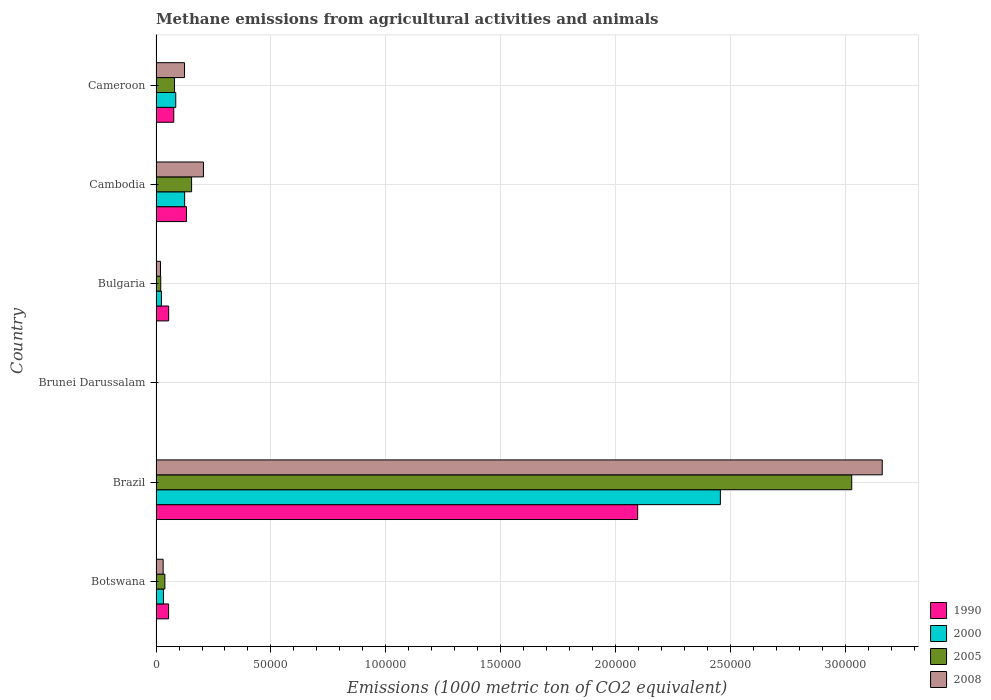How many groups of bars are there?
Offer a very short reply. 6. Are the number of bars on each tick of the Y-axis equal?
Provide a short and direct response. Yes. What is the label of the 2nd group of bars from the top?
Give a very brief answer. Cambodia. What is the amount of methane emitted in 1990 in Cambodia?
Ensure brevity in your answer.  1.32e+04. Across all countries, what is the maximum amount of methane emitted in 2000?
Your response must be concise. 2.45e+05. Across all countries, what is the minimum amount of methane emitted in 1990?
Ensure brevity in your answer.  12.5. In which country was the amount of methane emitted in 2005 minimum?
Provide a succinct answer. Brunei Darussalam. What is the total amount of methane emitted in 2000 in the graph?
Offer a terse response. 2.72e+05. What is the difference between the amount of methane emitted in 2008 in Cambodia and that in Cameroon?
Ensure brevity in your answer.  8220.9. What is the difference between the amount of methane emitted in 2008 in Cambodia and the amount of methane emitted in 2005 in Bulgaria?
Offer a terse response. 1.86e+04. What is the average amount of methane emitted in 2000 per country?
Provide a short and direct response. 4.54e+04. What is the difference between the amount of methane emitted in 2008 and amount of methane emitted in 2000 in Brazil?
Ensure brevity in your answer.  7.04e+04. In how many countries, is the amount of methane emitted in 2008 greater than 250000 1000 metric ton?
Make the answer very short. 1. What is the ratio of the amount of methane emitted in 2005 in Brunei Darussalam to that in Bulgaria?
Offer a very short reply. 0.01. Is the difference between the amount of methane emitted in 2008 in Botswana and Brunei Darussalam greater than the difference between the amount of methane emitted in 2000 in Botswana and Brunei Darussalam?
Keep it short and to the point. No. What is the difference between the highest and the second highest amount of methane emitted in 1990?
Offer a terse response. 1.96e+05. What is the difference between the highest and the lowest amount of methane emitted in 2000?
Offer a terse response. 2.45e+05. In how many countries, is the amount of methane emitted in 2000 greater than the average amount of methane emitted in 2000 taken over all countries?
Offer a very short reply. 1. Is it the case that in every country, the sum of the amount of methane emitted in 2005 and amount of methane emitted in 2008 is greater than the sum of amount of methane emitted in 2000 and amount of methane emitted in 1990?
Your response must be concise. No. What does the 4th bar from the top in Brazil represents?
Ensure brevity in your answer.  1990. What does the 4th bar from the bottom in Brazil represents?
Offer a terse response. 2008. Is it the case that in every country, the sum of the amount of methane emitted in 2008 and amount of methane emitted in 2005 is greater than the amount of methane emitted in 1990?
Your answer should be compact. No. Are all the bars in the graph horizontal?
Offer a terse response. Yes. How many countries are there in the graph?
Offer a terse response. 6. What is the difference between two consecutive major ticks on the X-axis?
Ensure brevity in your answer.  5.00e+04. Where does the legend appear in the graph?
Offer a terse response. Bottom right. How are the legend labels stacked?
Make the answer very short. Vertical. What is the title of the graph?
Provide a succinct answer. Methane emissions from agricultural activities and animals. What is the label or title of the X-axis?
Offer a terse response. Emissions (1000 metric ton of CO2 equivalent). What is the label or title of the Y-axis?
Your answer should be compact. Country. What is the Emissions (1000 metric ton of CO2 equivalent) in 1990 in Botswana?
Your answer should be compact. 5471.2. What is the Emissions (1000 metric ton of CO2 equivalent) in 2000 in Botswana?
Keep it short and to the point. 3234. What is the Emissions (1000 metric ton of CO2 equivalent) of 2005 in Botswana?
Your response must be concise. 3850.6. What is the Emissions (1000 metric ton of CO2 equivalent) in 2008 in Botswana?
Make the answer very short. 3096.4. What is the Emissions (1000 metric ton of CO2 equivalent) in 1990 in Brazil?
Your answer should be very brief. 2.10e+05. What is the Emissions (1000 metric ton of CO2 equivalent) of 2000 in Brazil?
Give a very brief answer. 2.45e+05. What is the Emissions (1000 metric ton of CO2 equivalent) of 2005 in Brazil?
Offer a very short reply. 3.03e+05. What is the Emissions (1000 metric ton of CO2 equivalent) in 2008 in Brazil?
Offer a terse response. 3.16e+05. What is the Emissions (1000 metric ton of CO2 equivalent) in 2008 in Brunei Darussalam?
Provide a short and direct response. 14.3. What is the Emissions (1000 metric ton of CO2 equivalent) in 1990 in Bulgaria?
Offer a very short reply. 5498.3. What is the Emissions (1000 metric ton of CO2 equivalent) of 2000 in Bulgaria?
Provide a succinct answer. 2359.5. What is the Emissions (1000 metric ton of CO2 equivalent) of 2005 in Bulgaria?
Offer a very short reply. 2055.2. What is the Emissions (1000 metric ton of CO2 equivalent) of 2008 in Bulgaria?
Give a very brief answer. 1942.2. What is the Emissions (1000 metric ton of CO2 equivalent) in 1990 in Cambodia?
Your response must be concise. 1.32e+04. What is the Emissions (1000 metric ton of CO2 equivalent) in 2000 in Cambodia?
Your response must be concise. 1.25e+04. What is the Emissions (1000 metric ton of CO2 equivalent) of 2005 in Cambodia?
Your response must be concise. 1.55e+04. What is the Emissions (1000 metric ton of CO2 equivalent) of 2008 in Cambodia?
Ensure brevity in your answer.  2.06e+04. What is the Emissions (1000 metric ton of CO2 equivalent) of 1990 in Cameroon?
Keep it short and to the point. 7719.8. What is the Emissions (1000 metric ton of CO2 equivalent) of 2000 in Cameroon?
Make the answer very short. 8579.6. What is the Emissions (1000 metric ton of CO2 equivalent) of 2005 in Cameroon?
Offer a very short reply. 8047.3. What is the Emissions (1000 metric ton of CO2 equivalent) in 2008 in Cameroon?
Provide a succinct answer. 1.24e+04. Across all countries, what is the maximum Emissions (1000 metric ton of CO2 equivalent) in 1990?
Your response must be concise. 2.10e+05. Across all countries, what is the maximum Emissions (1000 metric ton of CO2 equivalent) of 2000?
Give a very brief answer. 2.45e+05. Across all countries, what is the maximum Emissions (1000 metric ton of CO2 equivalent) of 2005?
Offer a terse response. 3.03e+05. Across all countries, what is the maximum Emissions (1000 metric ton of CO2 equivalent) of 2008?
Provide a succinct answer. 3.16e+05. Across all countries, what is the minimum Emissions (1000 metric ton of CO2 equivalent) in 2005?
Provide a succinct answer. 14.1. What is the total Emissions (1000 metric ton of CO2 equivalent) of 1990 in the graph?
Make the answer very short. 2.41e+05. What is the total Emissions (1000 metric ton of CO2 equivalent) in 2000 in the graph?
Provide a short and direct response. 2.72e+05. What is the total Emissions (1000 metric ton of CO2 equivalent) of 2005 in the graph?
Offer a very short reply. 3.32e+05. What is the total Emissions (1000 metric ton of CO2 equivalent) of 2008 in the graph?
Give a very brief answer. 3.54e+05. What is the difference between the Emissions (1000 metric ton of CO2 equivalent) of 1990 in Botswana and that in Brazil?
Your answer should be very brief. -2.04e+05. What is the difference between the Emissions (1000 metric ton of CO2 equivalent) of 2000 in Botswana and that in Brazil?
Your answer should be compact. -2.42e+05. What is the difference between the Emissions (1000 metric ton of CO2 equivalent) in 2005 in Botswana and that in Brazil?
Keep it short and to the point. -2.99e+05. What is the difference between the Emissions (1000 metric ton of CO2 equivalent) of 2008 in Botswana and that in Brazil?
Keep it short and to the point. -3.13e+05. What is the difference between the Emissions (1000 metric ton of CO2 equivalent) in 1990 in Botswana and that in Brunei Darussalam?
Give a very brief answer. 5458.7. What is the difference between the Emissions (1000 metric ton of CO2 equivalent) of 2000 in Botswana and that in Brunei Darussalam?
Your answer should be very brief. 3218.7. What is the difference between the Emissions (1000 metric ton of CO2 equivalent) of 2005 in Botswana and that in Brunei Darussalam?
Your answer should be very brief. 3836.5. What is the difference between the Emissions (1000 metric ton of CO2 equivalent) of 2008 in Botswana and that in Brunei Darussalam?
Your response must be concise. 3082.1. What is the difference between the Emissions (1000 metric ton of CO2 equivalent) in 1990 in Botswana and that in Bulgaria?
Offer a very short reply. -27.1. What is the difference between the Emissions (1000 metric ton of CO2 equivalent) in 2000 in Botswana and that in Bulgaria?
Give a very brief answer. 874.5. What is the difference between the Emissions (1000 metric ton of CO2 equivalent) of 2005 in Botswana and that in Bulgaria?
Ensure brevity in your answer.  1795.4. What is the difference between the Emissions (1000 metric ton of CO2 equivalent) in 2008 in Botswana and that in Bulgaria?
Your answer should be compact. 1154.2. What is the difference between the Emissions (1000 metric ton of CO2 equivalent) in 1990 in Botswana and that in Cambodia?
Your answer should be very brief. -7778.6. What is the difference between the Emissions (1000 metric ton of CO2 equivalent) in 2000 in Botswana and that in Cambodia?
Give a very brief answer. -9219.3. What is the difference between the Emissions (1000 metric ton of CO2 equivalent) of 2005 in Botswana and that in Cambodia?
Provide a short and direct response. -1.16e+04. What is the difference between the Emissions (1000 metric ton of CO2 equivalent) in 2008 in Botswana and that in Cambodia?
Provide a succinct answer. -1.75e+04. What is the difference between the Emissions (1000 metric ton of CO2 equivalent) in 1990 in Botswana and that in Cameroon?
Keep it short and to the point. -2248.6. What is the difference between the Emissions (1000 metric ton of CO2 equivalent) in 2000 in Botswana and that in Cameroon?
Offer a very short reply. -5345.6. What is the difference between the Emissions (1000 metric ton of CO2 equivalent) in 2005 in Botswana and that in Cameroon?
Give a very brief answer. -4196.7. What is the difference between the Emissions (1000 metric ton of CO2 equivalent) of 2008 in Botswana and that in Cameroon?
Ensure brevity in your answer.  -9314.9. What is the difference between the Emissions (1000 metric ton of CO2 equivalent) in 1990 in Brazil and that in Brunei Darussalam?
Keep it short and to the point. 2.10e+05. What is the difference between the Emissions (1000 metric ton of CO2 equivalent) in 2000 in Brazil and that in Brunei Darussalam?
Offer a terse response. 2.45e+05. What is the difference between the Emissions (1000 metric ton of CO2 equivalent) in 2005 in Brazil and that in Brunei Darussalam?
Your answer should be very brief. 3.03e+05. What is the difference between the Emissions (1000 metric ton of CO2 equivalent) of 2008 in Brazil and that in Brunei Darussalam?
Offer a very short reply. 3.16e+05. What is the difference between the Emissions (1000 metric ton of CO2 equivalent) of 1990 in Brazil and that in Bulgaria?
Give a very brief answer. 2.04e+05. What is the difference between the Emissions (1000 metric ton of CO2 equivalent) of 2000 in Brazil and that in Bulgaria?
Provide a succinct answer. 2.43e+05. What is the difference between the Emissions (1000 metric ton of CO2 equivalent) of 2005 in Brazil and that in Bulgaria?
Provide a short and direct response. 3.01e+05. What is the difference between the Emissions (1000 metric ton of CO2 equivalent) in 2008 in Brazil and that in Bulgaria?
Provide a succinct answer. 3.14e+05. What is the difference between the Emissions (1000 metric ton of CO2 equivalent) of 1990 in Brazil and that in Cambodia?
Offer a terse response. 1.96e+05. What is the difference between the Emissions (1000 metric ton of CO2 equivalent) of 2000 in Brazil and that in Cambodia?
Your response must be concise. 2.33e+05. What is the difference between the Emissions (1000 metric ton of CO2 equivalent) in 2005 in Brazil and that in Cambodia?
Your answer should be compact. 2.87e+05. What is the difference between the Emissions (1000 metric ton of CO2 equivalent) in 2008 in Brazil and that in Cambodia?
Give a very brief answer. 2.95e+05. What is the difference between the Emissions (1000 metric ton of CO2 equivalent) of 1990 in Brazil and that in Cameroon?
Offer a terse response. 2.02e+05. What is the difference between the Emissions (1000 metric ton of CO2 equivalent) in 2000 in Brazil and that in Cameroon?
Provide a short and direct response. 2.37e+05. What is the difference between the Emissions (1000 metric ton of CO2 equivalent) in 2005 in Brazil and that in Cameroon?
Offer a very short reply. 2.95e+05. What is the difference between the Emissions (1000 metric ton of CO2 equivalent) of 2008 in Brazil and that in Cameroon?
Make the answer very short. 3.03e+05. What is the difference between the Emissions (1000 metric ton of CO2 equivalent) in 1990 in Brunei Darussalam and that in Bulgaria?
Provide a succinct answer. -5485.8. What is the difference between the Emissions (1000 metric ton of CO2 equivalent) in 2000 in Brunei Darussalam and that in Bulgaria?
Keep it short and to the point. -2344.2. What is the difference between the Emissions (1000 metric ton of CO2 equivalent) in 2005 in Brunei Darussalam and that in Bulgaria?
Give a very brief answer. -2041.1. What is the difference between the Emissions (1000 metric ton of CO2 equivalent) of 2008 in Brunei Darussalam and that in Bulgaria?
Give a very brief answer. -1927.9. What is the difference between the Emissions (1000 metric ton of CO2 equivalent) in 1990 in Brunei Darussalam and that in Cambodia?
Provide a short and direct response. -1.32e+04. What is the difference between the Emissions (1000 metric ton of CO2 equivalent) in 2000 in Brunei Darussalam and that in Cambodia?
Provide a short and direct response. -1.24e+04. What is the difference between the Emissions (1000 metric ton of CO2 equivalent) of 2005 in Brunei Darussalam and that in Cambodia?
Make the answer very short. -1.55e+04. What is the difference between the Emissions (1000 metric ton of CO2 equivalent) of 2008 in Brunei Darussalam and that in Cambodia?
Ensure brevity in your answer.  -2.06e+04. What is the difference between the Emissions (1000 metric ton of CO2 equivalent) of 1990 in Brunei Darussalam and that in Cameroon?
Ensure brevity in your answer.  -7707.3. What is the difference between the Emissions (1000 metric ton of CO2 equivalent) of 2000 in Brunei Darussalam and that in Cameroon?
Your answer should be very brief. -8564.3. What is the difference between the Emissions (1000 metric ton of CO2 equivalent) of 2005 in Brunei Darussalam and that in Cameroon?
Provide a short and direct response. -8033.2. What is the difference between the Emissions (1000 metric ton of CO2 equivalent) of 2008 in Brunei Darussalam and that in Cameroon?
Your answer should be compact. -1.24e+04. What is the difference between the Emissions (1000 metric ton of CO2 equivalent) of 1990 in Bulgaria and that in Cambodia?
Keep it short and to the point. -7751.5. What is the difference between the Emissions (1000 metric ton of CO2 equivalent) of 2000 in Bulgaria and that in Cambodia?
Provide a short and direct response. -1.01e+04. What is the difference between the Emissions (1000 metric ton of CO2 equivalent) in 2005 in Bulgaria and that in Cambodia?
Offer a terse response. -1.34e+04. What is the difference between the Emissions (1000 metric ton of CO2 equivalent) of 2008 in Bulgaria and that in Cambodia?
Your response must be concise. -1.87e+04. What is the difference between the Emissions (1000 metric ton of CO2 equivalent) of 1990 in Bulgaria and that in Cameroon?
Offer a terse response. -2221.5. What is the difference between the Emissions (1000 metric ton of CO2 equivalent) of 2000 in Bulgaria and that in Cameroon?
Provide a succinct answer. -6220.1. What is the difference between the Emissions (1000 metric ton of CO2 equivalent) of 2005 in Bulgaria and that in Cameroon?
Ensure brevity in your answer.  -5992.1. What is the difference between the Emissions (1000 metric ton of CO2 equivalent) in 2008 in Bulgaria and that in Cameroon?
Ensure brevity in your answer.  -1.05e+04. What is the difference between the Emissions (1000 metric ton of CO2 equivalent) of 1990 in Cambodia and that in Cameroon?
Ensure brevity in your answer.  5530. What is the difference between the Emissions (1000 metric ton of CO2 equivalent) of 2000 in Cambodia and that in Cameroon?
Give a very brief answer. 3873.7. What is the difference between the Emissions (1000 metric ton of CO2 equivalent) in 2005 in Cambodia and that in Cameroon?
Give a very brief answer. 7429.6. What is the difference between the Emissions (1000 metric ton of CO2 equivalent) in 2008 in Cambodia and that in Cameroon?
Provide a short and direct response. 8220.9. What is the difference between the Emissions (1000 metric ton of CO2 equivalent) of 1990 in Botswana and the Emissions (1000 metric ton of CO2 equivalent) of 2000 in Brazil?
Ensure brevity in your answer.  -2.40e+05. What is the difference between the Emissions (1000 metric ton of CO2 equivalent) in 1990 in Botswana and the Emissions (1000 metric ton of CO2 equivalent) in 2005 in Brazil?
Ensure brevity in your answer.  -2.97e+05. What is the difference between the Emissions (1000 metric ton of CO2 equivalent) of 1990 in Botswana and the Emissions (1000 metric ton of CO2 equivalent) of 2008 in Brazil?
Provide a succinct answer. -3.10e+05. What is the difference between the Emissions (1000 metric ton of CO2 equivalent) in 2000 in Botswana and the Emissions (1000 metric ton of CO2 equivalent) in 2005 in Brazil?
Make the answer very short. -2.99e+05. What is the difference between the Emissions (1000 metric ton of CO2 equivalent) of 2000 in Botswana and the Emissions (1000 metric ton of CO2 equivalent) of 2008 in Brazil?
Your answer should be compact. -3.13e+05. What is the difference between the Emissions (1000 metric ton of CO2 equivalent) in 2005 in Botswana and the Emissions (1000 metric ton of CO2 equivalent) in 2008 in Brazil?
Your answer should be very brief. -3.12e+05. What is the difference between the Emissions (1000 metric ton of CO2 equivalent) in 1990 in Botswana and the Emissions (1000 metric ton of CO2 equivalent) in 2000 in Brunei Darussalam?
Give a very brief answer. 5455.9. What is the difference between the Emissions (1000 metric ton of CO2 equivalent) in 1990 in Botswana and the Emissions (1000 metric ton of CO2 equivalent) in 2005 in Brunei Darussalam?
Your answer should be very brief. 5457.1. What is the difference between the Emissions (1000 metric ton of CO2 equivalent) in 1990 in Botswana and the Emissions (1000 metric ton of CO2 equivalent) in 2008 in Brunei Darussalam?
Your response must be concise. 5456.9. What is the difference between the Emissions (1000 metric ton of CO2 equivalent) in 2000 in Botswana and the Emissions (1000 metric ton of CO2 equivalent) in 2005 in Brunei Darussalam?
Make the answer very short. 3219.9. What is the difference between the Emissions (1000 metric ton of CO2 equivalent) of 2000 in Botswana and the Emissions (1000 metric ton of CO2 equivalent) of 2008 in Brunei Darussalam?
Offer a terse response. 3219.7. What is the difference between the Emissions (1000 metric ton of CO2 equivalent) in 2005 in Botswana and the Emissions (1000 metric ton of CO2 equivalent) in 2008 in Brunei Darussalam?
Ensure brevity in your answer.  3836.3. What is the difference between the Emissions (1000 metric ton of CO2 equivalent) in 1990 in Botswana and the Emissions (1000 metric ton of CO2 equivalent) in 2000 in Bulgaria?
Provide a short and direct response. 3111.7. What is the difference between the Emissions (1000 metric ton of CO2 equivalent) in 1990 in Botswana and the Emissions (1000 metric ton of CO2 equivalent) in 2005 in Bulgaria?
Make the answer very short. 3416. What is the difference between the Emissions (1000 metric ton of CO2 equivalent) of 1990 in Botswana and the Emissions (1000 metric ton of CO2 equivalent) of 2008 in Bulgaria?
Your response must be concise. 3529. What is the difference between the Emissions (1000 metric ton of CO2 equivalent) of 2000 in Botswana and the Emissions (1000 metric ton of CO2 equivalent) of 2005 in Bulgaria?
Provide a succinct answer. 1178.8. What is the difference between the Emissions (1000 metric ton of CO2 equivalent) of 2000 in Botswana and the Emissions (1000 metric ton of CO2 equivalent) of 2008 in Bulgaria?
Your answer should be compact. 1291.8. What is the difference between the Emissions (1000 metric ton of CO2 equivalent) of 2005 in Botswana and the Emissions (1000 metric ton of CO2 equivalent) of 2008 in Bulgaria?
Provide a succinct answer. 1908.4. What is the difference between the Emissions (1000 metric ton of CO2 equivalent) of 1990 in Botswana and the Emissions (1000 metric ton of CO2 equivalent) of 2000 in Cambodia?
Your response must be concise. -6982.1. What is the difference between the Emissions (1000 metric ton of CO2 equivalent) in 1990 in Botswana and the Emissions (1000 metric ton of CO2 equivalent) in 2005 in Cambodia?
Provide a short and direct response. -1.00e+04. What is the difference between the Emissions (1000 metric ton of CO2 equivalent) of 1990 in Botswana and the Emissions (1000 metric ton of CO2 equivalent) of 2008 in Cambodia?
Offer a terse response. -1.52e+04. What is the difference between the Emissions (1000 metric ton of CO2 equivalent) of 2000 in Botswana and the Emissions (1000 metric ton of CO2 equivalent) of 2005 in Cambodia?
Ensure brevity in your answer.  -1.22e+04. What is the difference between the Emissions (1000 metric ton of CO2 equivalent) in 2000 in Botswana and the Emissions (1000 metric ton of CO2 equivalent) in 2008 in Cambodia?
Offer a very short reply. -1.74e+04. What is the difference between the Emissions (1000 metric ton of CO2 equivalent) of 2005 in Botswana and the Emissions (1000 metric ton of CO2 equivalent) of 2008 in Cambodia?
Your answer should be compact. -1.68e+04. What is the difference between the Emissions (1000 metric ton of CO2 equivalent) in 1990 in Botswana and the Emissions (1000 metric ton of CO2 equivalent) in 2000 in Cameroon?
Your answer should be very brief. -3108.4. What is the difference between the Emissions (1000 metric ton of CO2 equivalent) in 1990 in Botswana and the Emissions (1000 metric ton of CO2 equivalent) in 2005 in Cameroon?
Your answer should be compact. -2576.1. What is the difference between the Emissions (1000 metric ton of CO2 equivalent) in 1990 in Botswana and the Emissions (1000 metric ton of CO2 equivalent) in 2008 in Cameroon?
Your response must be concise. -6940.1. What is the difference between the Emissions (1000 metric ton of CO2 equivalent) of 2000 in Botswana and the Emissions (1000 metric ton of CO2 equivalent) of 2005 in Cameroon?
Your answer should be very brief. -4813.3. What is the difference between the Emissions (1000 metric ton of CO2 equivalent) of 2000 in Botswana and the Emissions (1000 metric ton of CO2 equivalent) of 2008 in Cameroon?
Keep it short and to the point. -9177.3. What is the difference between the Emissions (1000 metric ton of CO2 equivalent) of 2005 in Botswana and the Emissions (1000 metric ton of CO2 equivalent) of 2008 in Cameroon?
Offer a terse response. -8560.7. What is the difference between the Emissions (1000 metric ton of CO2 equivalent) of 1990 in Brazil and the Emissions (1000 metric ton of CO2 equivalent) of 2000 in Brunei Darussalam?
Keep it short and to the point. 2.10e+05. What is the difference between the Emissions (1000 metric ton of CO2 equivalent) in 1990 in Brazil and the Emissions (1000 metric ton of CO2 equivalent) in 2005 in Brunei Darussalam?
Give a very brief answer. 2.10e+05. What is the difference between the Emissions (1000 metric ton of CO2 equivalent) in 1990 in Brazil and the Emissions (1000 metric ton of CO2 equivalent) in 2008 in Brunei Darussalam?
Give a very brief answer. 2.10e+05. What is the difference between the Emissions (1000 metric ton of CO2 equivalent) of 2000 in Brazil and the Emissions (1000 metric ton of CO2 equivalent) of 2005 in Brunei Darussalam?
Keep it short and to the point. 2.45e+05. What is the difference between the Emissions (1000 metric ton of CO2 equivalent) in 2000 in Brazil and the Emissions (1000 metric ton of CO2 equivalent) in 2008 in Brunei Darussalam?
Offer a very short reply. 2.45e+05. What is the difference between the Emissions (1000 metric ton of CO2 equivalent) of 2005 in Brazil and the Emissions (1000 metric ton of CO2 equivalent) of 2008 in Brunei Darussalam?
Ensure brevity in your answer.  3.03e+05. What is the difference between the Emissions (1000 metric ton of CO2 equivalent) of 1990 in Brazil and the Emissions (1000 metric ton of CO2 equivalent) of 2000 in Bulgaria?
Provide a short and direct response. 2.07e+05. What is the difference between the Emissions (1000 metric ton of CO2 equivalent) of 1990 in Brazil and the Emissions (1000 metric ton of CO2 equivalent) of 2005 in Bulgaria?
Offer a terse response. 2.07e+05. What is the difference between the Emissions (1000 metric ton of CO2 equivalent) in 1990 in Brazil and the Emissions (1000 metric ton of CO2 equivalent) in 2008 in Bulgaria?
Your response must be concise. 2.08e+05. What is the difference between the Emissions (1000 metric ton of CO2 equivalent) of 2000 in Brazil and the Emissions (1000 metric ton of CO2 equivalent) of 2005 in Bulgaria?
Your answer should be compact. 2.43e+05. What is the difference between the Emissions (1000 metric ton of CO2 equivalent) in 2000 in Brazil and the Emissions (1000 metric ton of CO2 equivalent) in 2008 in Bulgaria?
Ensure brevity in your answer.  2.44e+05. What is the difference between the Emissions (1000 metric ton of CO2 equivalent) in 2005 in Brazil and the Emissions (1000 metric ton of CO2 equivalent) in 2008 in Bulgaria?
Keep it short and to the point. 3.01e+05. What is the difference between the Emissions (1000 metric ton of CO2 equivalent) in 1990 in Brazil and the Emissions (1000 metric ton of CO2 equivalent) in 2000 in Cambodia?
Ensure brevity in your answer.  1.97e+05. What is the difference between the Emissions (1000 metric ton of CO2 equivalent) of 1990 in Brazil and the Emissions (1000 metric ton of CO2 equivalent) of 2005 in Cambodia?
Ensure brevity in your answer.  1.94e+05. What is the difference between the Emissions (1000 metric ton of CO2 equivalent) in 1990 in Brazil and the Emissions (1000 metric ton of CO2 equivalent) in 2008 in Cambodia?
Provide a succinct answer. 1.89e+05. What is the difference between the Emissions (1000 metric ton of CO2 equivalent) in 2000 in Brazil and the Emissions (1000 metric ton of CO2 equivalent) in 2005 in Cambodia?
Your answer should be compact. 2.30e+05. What is the difference between the Emissions (1000 metric ton of CO2 equivalent) of 2000 in Brazil and the Emissions (1000 metric ton of CO2 equivalent) of 2008 in Cambodia?
Your answer should be very brief. 2.25e+05. What is the difference between the Emissions (1000 metric ton of CO2 equivalent) in 2005 in Brazil and the Emissions (1000 metric ton of CO2 equivalent) in 2008 in Cambodia?
Provide a succinct answer. 2.82e+05. What is the difference between the Emissions (1000 metric ton of CO2 equivalent) of 1990 in Brazil and the Emissions (1000 metric ton of CO2 equivalent) of 2000 in Cameroon?
Provide a succinct answer. 2.01e+05. What is the difference between the Emissions (1000 metric ton of CO2 equivalent) of 1990 in Brazil and the Emissions (1000 metric ton of CO2 equivalent) of 2005 in Cameroon?
Give a very brief answer. 2.01e+05. What is the difference between the Emissions (1000 metric ton of CO2 equivalent) of 1990 in Brazil and the Emissions (1000 metric ton of CO2 equivalent) of 2008 in Cameroon?
Keep it short and to the point. 1.97e+05. What is the difference between the Emissions (1000 metric ton of CO2 equivalent) of 2000 in Brazil and the Emissions (1000 metric ton of CO2 equivalent) of 2005 in Cameroon?
Offer a terse response. 2.37e+05. What is the difference between the Emissions (1000 metric ton of CO2 equivalent) in 2000 in Brazil and the Emissions (1000 metric ton of CO2 equivalent) in 2008 in Cameroon?
Keep it short and to the point. 2.33e+05. What is the difference between the Emissions (1000 metric ton of CO2 equivalent) of 2005 in Brazil and the Emissions (1000 metric ton of CO2 equivalent) of 2008 in Cameroon?
Your response must be concise. 2.90e+05. What is the difference between the Emissions (1000 metric ton of CO2 equivalent) of 1990 in Brunei Darussalam and the Emissions (1000 metric ton of CO2 equivalent) of 2000 in Bulgaria?
Ensure brevity in your answer.  -2347. What is the difference between the Emissions (1000 metric ton of CO2 equivalent) in 1990 in Brunei Darussalam and the Emissions (1000 metric ton of CO2 equivalent) in 2005 in Bulgaria?
Offer a very short reply. -2042.7. What is the difference between the Emissions (1000 metric ton of CO2 equivalent) in 1990 in Brunei Darussalam and the Emissions (1000 metric ton of CO2 equivalent) in 2008 in Bulgaria?
Ensure brevity in your answer.  -1929.7. What is the difference between the Emissions (1000 metric ton of CO2 equivalent) of 2000 in Brunei Darussalam and the Emissions (1000 metric ton of CO2 equivalent) of 2005 in Bulgaria?
Make the answer very short. -2039.9. What is the difference between the Emissions (1000 metric ton of CO2 equivalent) of 2000 in Brunei Darussalam and the Emissions (1000 metric ton of CO2 equivalent) of 2008 in Bulgaria?
Provide a short and direct response. -1926.9. What is the difference between the Emissions (1000 metric ton of CO2 equivalent) in 2005 in Brunei Darussalam and the Emissions (1000 metric ton of CO2 equivalent) in 2008 in Bulgaria?
Your response must be concise. -1928.1. What is the difference between the Emissions (1000 metric ton of CO2 equivalent) of 1990 in Brunei Darussalam and the Emissions (1000 metric ton of CO2 equivalent) of 2000 in Cambodia?
Provide a short and direct response. -1.24e+04. What is the difference between the Emissions (1000 metric ton of CO2 equivalent) of 1990 in Brunei Darussalam and the Emissions (1000 metric ton of CO2 equivalent) of 2005 in Cambodia?
Give a very brief answer. -1.55e+04. What is the difference between the Emissions (1000 metric ton of CO2 equivalent) in 1990 in Brunei Darussalam and the Emissions (1000 metric ton of CO2 equivalent) in 2008 in Cambodia?
Ensure brevity in your answer.  -2.06e+04. What is the difference between the Emissions (1000 metric ton of CO2 equivalent) in 2000 in Brunei Darussalam and the Emissions (1000 metric ton of CO2 equivalent) in 2005 in Cambodia?
Give a very brief answer. -1.55e+04. What is the difference between the Emissions (1000 metric ton of CO2 equivalent) in 2000 in Brunei Darussalam and the Emissions (1000 metric ton of CO2 equivalent) in 2008 in Cambodia?
Ensure brevity in your answer.  -2.06e+04. What is the difference between the Emissions (1000 metric ton of CO2 equivalent) in 2005 in Brunei Darussalam and the Emissions (1000 metric ton of CO2 equivalent) in 2008 in Cambodia?
Ensure brevity in your answer.  -2.06e+04. What is the difference between the Emissions (1000 metric ton of CO2 equivalent) of 1990 in Brunei Darussalam and the Emissions (1000 metric ton of CO2 equivalent) of 2000 in Cameroon?
Keep it short and to the point. -8567.1. What is the difference between the Emissions (1000 metric ton of CO2 equivalent) of 1990 in Brunei Darussalam and the Emissions (1000 metric ton of CO2 equivalent) of 2005 in Cameroon?
Provide a short and direct response. -8034.8. What is the difference between the Emissions (1000 metric ton of CO2 equivalent) of 1990 in Brunei Darussalam and the Emissions (1000 metric ton of CO2 equivalent) of 2008 in Cameroon?
Ensure brevity in your answer.  -1.24e+04. What is the difference between the Emissions (1000 metric ton of CO2 equivalent) of 2000 in Brunei Darussalam and the Emissions (1000 metric ton of CO2 equivalent) of 2005 in Cameroon?
Your answer should be very brief. -8032. What is the difference between the Emissions (1000 metric ton of CO2 equivalent) in 2000 in Brunei Darussalam and the Emissions (1000 metric ton of CO2 equivalent) in 2008 in Cameroon?
Provide a succinct answer. -1.24e+04. What is the difference between the Emissions (1000 metric ton of CO2 equivalent) of 2005 in Brunei Darussalam and the Emissions (1000 metric ton of CO2 equivalent) of 2008 in Cameroon?
Give a very brief answer. -1.24e+04. What is the difference between the Emissions (1000 metric ton of CO2 equivalent) in 1990 in Bulgaria and the Emissions (1000 metric ton of CO2 equivalent) in 2000 in Cambodia?
Keep it short and to the point. -6955. What is the difference between the Emissions (1000 metric ton of CO2 equivalent) of 1990 in Bulgaria and the Emissions (1000 metric ton of CO2 equivalent) of 2005 in Cambodia?
Offer a terse response. -9978.6. What is the difference between the Emissions (1000 metric ton of CO2 equivalent) in 1990 in Bulgaria and the Emissions (1000 metric ton of CO2 equivalent) in 2008 in Cambodia?
Ensure brevity in your answer.  -1.51e+04. What is the difference between the Emissions (1000 metric ton of CO2 equivalent) in 2000 in Bulgaria and the Emissions (1000 metric ton of CO2 equivalent) in 2005 in Cambodia?
Make the answer very short. -1.31e+04. What is the difference between the Emissions (1000 metric ton of CO2 equivalent) in 2000 in Bulgaria and the Emissions (1000 metric ton of CO2 equivalent) in 2008 in Cambodia?
Keep it short and to the point. -1.83e+04. What is the difference between the Emissions (1000 metric ton of CO2 equivalent) in 2005 in Bulgaria and the Emissions (1000 metric ton of CO2 equivalent) in 2008 in Cambodia?
Make the answer very short. -1.86e+04. What is the difference between the Emissions (1000 metric ton of CO2 equivalent) in 1990 in Bulgaria and the Emissions (1000 metric ton of CO2 equivalent) in 2000 in Cameroon?
Offer a very short reply. -3081.3. What is the difference between the Emissions (1000 metric ton of CO2 equivalent) of 1990 in Bulgaria and the Emissions (1000 metric ton of CO2 equivalent) of 2005 in Cameroon?
Your answer should be compact. -2549. What is the difference between the Emissions (1000 metric ton of CO2 equivalent) in 1990 in Bulgaria and the Emissions (1000 metric ton of CO2 equivalent) in 2008 in Cameroon?
Make the answer very short. -6913. What is the difference between the Emissions (1000 metric ton of CO2 equivalent) in 2000 in Bulgaria and the Emissions (1000 metric ton of CO2 equivalent) in 2005 in Cameroon?
Keep it short and to the point. -5687.8. What is the difference between the Emissions (1000 metric ton of CO2 equivalent) in 2000 in Bulgaria and the Emissions (1000 metric ton of CO2 equivalent) in 2008 in Cameroon?
Your answer should be compact. -1.01e+04. What is the difference between the Emissions (1000 metric ton of CO2 equivalent) in 2005 in Bulgaria and the Emissions (1000 metric ton of CO2 equivalent) in 2008 in Cameroon?
Give a very brief answer. -1.04e+04. What is the difference between the Emissions (1000 metric ton of CO2 equivalent) in 1990 in Cambodia and the Emissions (1000 metric ton of CO2 equivalent) in 2000 in Cameroon?
Your answer should be very brief. 4670.2. What is the difference between the Emissions (1000 metric ton of CO2 equivalent) of 1990 in Cambodia and the Emissions (1000 metric ton of CO2 equivalent) of 2005 in Cameroon?
Your response must be concise. 5202.5. What is the difference between the Emissions (1000 metric ton of CO2 equivalent) in 1990 in Cambodia and the Emissions (1000 metric ton of CO2 equivalent) in 2008 in Cameroon?
Keep it short and to the point. 838.5. What is the difference between the Emissions (1000 metric ton of CO2 equivalent) in 2000 in Cambodia and the Emissions (1000 metric ton of CO2 equivalent) in 2005 in Cameroon?
Your response must be concise. 4406. What is the difference between the Emissions (1000 metric ton of CO2 equivalent) of 2000 in Cambodia and the Emissions (1000 metric ton of CO2 equivalent) of 2008 in Cameroon?
Provide a short and direct response. 42. What is the difference between the Emissions (1000 metric ton of CO2 equivalent) of 2005 in Cambodia and the Emissions (1000 metric ton of CO2 equivalent) of 2008 in Cameroon?
Offer a terse response. 3065.6. What is the average Emissions (1000 metric ton of CO2 equivalent) of 1990 per country?
Provide a succinct answer. 4.02e+04. What is the average Emissions (1000 metric ton of CO2 equivalent) in 2000 per country?
Make the answer very short. 4.54e+04. What is the average Emissions (1000 metric ton of CO2 equivalent) in 2005 per country?
Your response must be concise. 5.53e+04. What is the average Emissions (1000 metric ton of CO2 equivalent) in 2008 per country?
Keep it short and to the point. 5.90e+04. What is the difference between the Emissions (1000 metric ton of CO2 equivalent) in 1990 and Emissions (1000 metric ton of CO2 equivalent) in 2000 in Botswana?
Offer a very short reply. 2237.2. What is the difference between the Emissions (1000 metric ton of CO2 equivalent) of 1990 and Emissions (1000 metric ton of CO2 equivalent) of 2005 in Botswana?
Give a very brief answer. 1620.6. What is the difference between the Emissions (1000 metric ton of CO2 equivalent) in 1990 and Emissions (1000 metric ton of CO2 equivalent) in 2008 in Botswana?
Provide a short and direct response. 2374.8. What is the difference between the Emissions (1000 metric ton of CO2 equivalent) in 2000 and Emissions (1000 metric ton of CO2 equivalent) in 2005 in Botswana?
Offer a terse response. -616.6. What is the difference between the Emissions (1000 metric ton of CO2 equivalent) in 2000 and Emissions (1000 metric ton of CO2 equivalent) in 2008 in Botswana?
Make the answer very short. 137.6. What is the difference between the Emissions (1000 metric ton of CO2 equivalent) of 2005 and Emissions (1000 metric ton of CO2 equivalent) of 2008 in Botswana?
Give a very brief answer. 754.2. What is the difference between the Emissions (1000 metric ton of CO2 equivalent) of 1990 and Emissions (1000 metric ton of CO2 equivalent) of 2000 in Brazil?
Offer a very short reply. -3.60e+04. What is the difference between the Emissions (1000 metric ton of CO2 equivalent) in 1990 and Emissions (1000 metric ton of CO2 equivalent) in 2005 in Brazil?
Make the answer very short. -9.31e+04. What is the difference between the Emissions (1000 metric ton of CO2 equivalent) in 1990 and Emissions (1000 metric ton of CO2 equivalent) in 2008 in Brazil?
Provide a short and direct response. -1.06e+05. What is the difference between the Emissions (1000 metric ton of CO2 equivalent) of 2000 and Emissions (1000 metric ton of CO2 equivalent) of 2005 in Brazil?
Ensure brevity in your answer.  -5.71e+04. What is the difference between the Emissions (1000 metric ton of CO2 equivalent) in 2000 and Emissions (1000 metric ton of CO2 equivalent) in 2008 in Brazil?
Offer a terse response. -7.04e+04. What is the difference between the Emissions (1000 metric ton of CO2 equivalent) of 2005 and Emissions (1000 metric ton of CO2 equivalent) of 2008 in Brazil?
Provide a succinct answer. -1.33e+04. What is the difference between the Emissions (1000 metric ton of CO2 equivalent) in 1990 and Emissions (1000 metric ton of CO2 equivalent) in 2000 in Brunei Darussalam?
Ensure brevity in your answer.  -2.8. What is the difference between the Emissions (1000 metric ton of CO2 equivalent) of 1990 and Emissions (1000 metric ton of CO2 equivalent) of 2008 in Brunei Darussalam?
Provide a short and direct response. -1.8. What is the difference between the Emissions (1000 metric ton of CO2 equivalent) of 2000 and Emissions (1000 metric ton of CO2 equivalent) of 2008 in Brunei Darussalam?
Ensure brevity in your answer.  1. What is the difference between the Emissions (1000 metric ton of CO2 equivalent) of 2005 and Emissions (1000 metric ton of CO2 equivalent) of 2008 in Brunei Darussalam?
Your answer should be compact. -0.2. What is the difference between the Emissions (1000 metric ton of CO2 equivalent) in 1990 and Emissions (1000 metric ton of CO2 equivalent) in 2000 in Bulgaria?
Offer a very short reply. 3138.8. What is the difference between the Emissions (1000 metric ton of CO2 equivalent) in 1990 and Emissions (1000 metric ton of CO2 equivalent) in 2005 in Bulgaria?
Ensure brevity in your answer.  3443.1. What is the difference between the Emissions (1000 metric ton of CO2 equivalent) in 1990 and Emissions (1000 metric ton of CO2 equivalent) in 2008 in Bulgaria?
Keep it short and to the point. 3556.1. What is the difference between the Emissions (1000 metric ton of CO2 equivalent) of 2000 and Emissions (1000 metric ton of CO2 equivalent) of 2005 in Bulgaria?
Give a very brief answer. 304.3. What is the difference between the Emissions (1000 metric ton of CO2 equivalent) of 2000 and Emissions (1000 metric ton of CO2 equivalent) of 2008 in Bulgaria?
Your response must be concise. 417.3. What is the difference between the Emissions (1000 metric ton of CO2 equivalent) in 2005 and Emissions (1000 metric ton of CO2 equivalent) in 2008 in Bulgaria?
Your answer should be very brief. 113. What is the difference between the Emissions (1000 metric ton of CO2 equivalent) of 1990 and Emissions (1000 metric ton of CO2 equivalent) of 2000 in Cambodia?
Provide a succinct answer. 796.5. What is the difference between the Emissions (1000 metric ton of CO2 equivalent) of 1990 and Emissions (1000 metric ton of CO2 equivalent) of 2005 in Cambodia?
Make the answer very short. -2227.1. What is the difference between the Emissions (1000 metric ton of CO2 equivalent) of 1990 and Emissions (1000 metric ton of CO2 equivalent) of 2008 in Cambodia?
Your answer should be very brief. -7382.4. What is the difference between the Emissions (1000 metric ton of CO2 equivalent) of 2000 and Emissions (1000 metric ton of CO2 equivalent) of 2005 in Cambodia?
Keep it short and to the point. -3023.6. What is the difference between the Emissions (1000 metric ton of CO2 equivalent) of 2000 and Emissions (1000 metric ton of CO2 equivalent) of 2008 in Cambodia?
Make the answer very short. -8178.9. What is the difference between the Emissions (1000 metric ton of CO2 equivalent) of 2005 and Emissions (1000 metric ton of CO2 equivalent) of 2008 in Cambodia?
Make the answer very short. -5155.3. What is the difference between the Emissions (1000 metric ton of CO2 equivalent) in 1990 and Emissions (1000 metric ton of CO2 equivalent) in 2000 in Cameroon?
Offer a very short reply. -859.8. What is the difference between the Emissions (1000 metric ton of CO2 equivalent) of 1990 and Emissions (1000 metric ton of CO2 equivalent) of 2005 in Cameroon?
Your answer should be compact. -327.5. What is the difference between the Emissions (1000 metric ton of CO2 equivalent) of 1990 and Emissions (1000 metric ton of CO2 equivalent) of 2008 in Cameroon?
Your response must be concise. -4691.5. What is the difference between the Emissions (1000 metric ton of CO2 equivalent) in 2000 and Emissions (1000 metric ton of CO2 equivalent) in 2005 in Cameroon?
Make the answer very short. 532.3. What is the difference between the Emissions (1000 metric ton of CO2 equivalent) in 2000 and Emissions (1000 metric ton of CO2 equivalent) in 2008 in Cameroon?
Offer a terse response. -3831.7. What is the difference between the Emissions (1000 metric ton of CO2 equivalent) in 2005 and Emissions (1000 metric ton of CO2 equivalent) in 2008 in Cameroon?
Ensure brevity in your answer.  -4364. What is the ratio of the Emissions (1000 metric ton of CO2 equivalent) of 1990 in Botswana to that in Brazil?
Your response must be concise. 0.03. What is the ratio of the Emissions (1000 metric ton of CO2 equivalent) in 2000 in Botswana to that in Brazil?
Your answer should be compact. 0.01. What is the ratio of the Emissions (1000 metric ton of CO2 equivalent) of 2005 in Botswana to that in Brazil?
Your answer should be compact. 0.01. What is the ratio of the Emissions (1000 metric ton of CO2 equivalent) of 2008 in Botswana to that in Brazil?
Provide a short and direct response. 0.01. What is the ratio of the Emissions (1000 metric ton of CO2 equivalent) of 1990 in Botswana to that in Brunei Darussalam?
Provide a short and direct response. 437.7. What is the ratio of the Emissions (1000 metric ton of CO2 equivalent) of 2000 in Botswana to that in Brunei Darussalam?
Ensure brevity in your answer.  211.37. What is the ratio of the Emissions (1000 metric ton of CO2 equivalent) of 2005 in Botswana to that in Brunei Darussalam?
Provide a succinct answer. 273.09. What is the ratio of the Emissions (1000 metric ton of CO2 equivalent) of 2008 in Botswana to that in Brunei Darussalam?
Provide a succinct answer. 216.53. What is the ratio of the Emissions (1000 metric ton of CO2 equivalent) in 1990 in Botswana to that in Bulgaria?
Provide a succinct answer. 1. What is the ratio of the Emissions (1000 metric ton of CO2 equivalent) of 2000 in Botswana to that in Bulgaria?
Your answer should be very brief. 1.37. What is the ratio of the Emissions (1000 metric ton of CO2 equivalent) in 2005 in Botswana to that in Bulgaria?
Make the answer very short. 1.87. What is the ratio of the Emissions (1000 metric ton of CO2 equivalent) of 2008 in Botswana to that in Bulgaria?
Your answer should be very brief. 1.59. What is the ratio of the Emissions (1000 metric ton of CO2 equivalent) of 1990 in Botswana to that in Cambodia?
Give a very brief answer. 0.41. What is the ratio of the Emissions (1000 metric ton of CO2 equivalent) in 2000 in Botswana to that in Cambodia?
Offer a very short reply. 0.26. What is the ratio of the Emissions (1000 metric ton of CO2 equivalent) in 2005 in Botswana to that in Cambodia?
Provide a succinct answer. 0.25. What is the ratio of the Emissions (1000 metric ton of CO2 equivalent) of 2008 in Botswana to that in Cambodia?
Your response must be concise. 0.15. What is the ratio of the Emissions (1000 metric ton of CO2 equivalent) in 1990 in Botswana to that in Cameroon?
Offer a terse response. 0.71. What is the ratio of the Emissions (1000 metric ton of CO2 equivalent) in 2000 in Botswana to that in Cameroon?
Your answer should be compact. 0.38. What is the ratio of the Emissions (1000 metric ton of CO2 equivalent) in 2005 in Botswana to that in Cameroon?
Make the answer very short. 0.48. What is the ratio of the Emissions (1000 metric ton of CO2 equivalent) of 2008 in Botswana to that in Cameroon?
Provide a succinct answer. 0.25. What is the ratio of the Emissions (1000 metric ton of CO2 equivalent) in 1990 in Brazil to that in Brunei Darussalam?
Offer a very short reply. 1.68e+04. What is the ratio of the Emissions (1000 metric ton of CO2 equivalent) of 2000 in Brazil to that in Brunei Darussalam?
Offer a very short reply. 1.60e+04. What is the ratio of the Emissions (1000 metric ton of CO2 equivalent) in 2005 in Brazil to that in Brunei Darussalam?
Keep it short and to the point. 2.15e+04. What is the ratio of the Emissions (1000 metric ton of CO2 equivalent) in 2008 in Brazil to that in Brunei Darussalam?
Your answer should be compact. 2.21e+04. What is the ratio of the Emissions (1000 metric ton of CO2 equivalent) in 1990 in Brazil to that in Bulgaria?
Offer a terse response. 38.11. What is the ratio of the Emissions (1000 metric ton of CO2 equivalent) of 2000 in Brazil to that in Bulgaria?
Offer a terse response. 104.05. What is the ratio of the Emissions (1000 metric ton of CO2 equivalent) in 2005 in Brazil to that in Bulgaria?
Your answer should be very brief. 147.25. What is the ratio of the Emissions (1000 metric ton of CO2 equivalent) of 2008 in Brazil to that in Bulgaria?
Give a very brief answer. 162.66. What is the ratio of the Emissions (1000 metric ton of CO2 equivalent) of 1990 in Brazil to that in Cambodia?
Offer a very short reply. 15.81. What is the ratio of the Emissions (1000 metric ton of CO2 equivalent) of 2000 in Brazil to that in Cambodia?
Give a very brief answer. 19.71. What is the ratio of the Emissions (1000 metric ton of CO2 equivalent) of 2005 in Brazil to that in Cambodia?
Provide a succinct answer. 19.55. What is the ratio of the Emissions (1000 metric ton of CO2 equivalent) of 2008 in Brazil to that in Cambodia?
Provide a short and direct response. 15.31. What is the ratio of the Emissions (1000 metric ton of CO2 equivalent) of 1990 in Brazil to that in Cameroon?
Make the answer very short. 27.14. What is the ratio of the Emissions (1000 metric ton of CO2 equivalent) in 2000 in Brazil to that in Cameroon?
Offer a very short reply. 28.61. What is the ratio of the Emissions (1000 metric ton of CO2 equivalent) in 2005 in Brazil to that in Cameroon?
Offer a very short reply. 37.61. What is the ratio of the Emissions (1000 metric ton of CO2 equivalent) of 2008 in Brazil to that in Cameroon?
Your answer should be compact. 25.45. What is the ratio of the Emissions (1000 metric ton of CO2 equivalent) in 1990 in Brunei Darussalam to that in Bulgaria?
Keep it short and to the point. 0. What is the ratio of the Emissions (1000 metric ton of CO2 equivalent) in 2000 in Brunei Darussalam to that in Bulgaria?
Provide a short and direct response. 0.01. What is the ratio of the Emissions (1000 metric ton of CO2 equivalent) in 2005 in Brunei Darussalam to that in Bulgaria?
Ensure brevity in your answer.  0.01. What is the ratio of the Emissions (1000 metric ton of CO2 equivalent) in 2008 in Brunei Darussalam to that in Bulgaria?
Ensure brevity in your answer.  0.01. What is the ratio of the Emissions (1000 metric ton of CO2 equivalent) of 1990 in Brunei Darussalam to that in Cambodia?
Your answer should be very brief. 0. What is the ratio of the Emissions (1000 metric ton of CO2 equivalent) in 2000 in Brunei Darussalam to that in Cambodia?
Keep it short and to the point. 0. What is the ratio of the Emissions (1000 metric ton of CO2 equivalent) in 2005 in Brunei Darussalam to that in Cambodia?
Your answer should be compact. 0. What is the ratio of the Emissions (1000 metric ton of CO2 equivalent) of 2008 in Brunei Darussalam to that in Cambodia?
Provide a short and direct response. 0. What is the ratio of the Emissions (1000 metric ton of CO2 equivalent) in 1990 in Brunei Darussalam to that in Cameroon?
Keep it short and to the point. 0. What is the ratio of the Emissions (1000 metric ton of CO2 equivalent) in 2000 in Brunei Darussalam to that in Cameroon?
Offer a terse response. 0. What is the ratio of the Emissions (1000 metric ton of CO2 equivalent) of 2005 in Brunei Darussalam to that in Cameroon?
Your answer should be very brief. 0. What is the ratio of the Emissions (1000 metric ton of CO2 equivalent) in 2008 in Brunei Darussalam to that in Cameroon?
Your answer should be compact. 0. What is the ratio of the Emissions (1000 metric ton of CO2 equivalent) in 1990 in Bulgaria to that in Cambodia?
Your answer should be compact. 0.41. What is the ratio of the Emissions (1000 metric ton of CO2 equivalent) in 2000 in Bulgaria to that in Cambodia?
Your answer should be compact. 0.19. What is the ratio of the Emissions (1000 metric ton of CO2 equivalent) of 2005 in Bulgaria to that in Cambodia?
Keep it short and to the point. 0.13. What is the ratio of the Emissions (1000 metric ton of CO2 equivalent) in 2008 in Bulgaria to that in Cambodia?
Your answer should be very brief. 0.09. What is the ratio of the Emissions (1000 metric ton of CO2 equivalent) in 1990 in Bulgaria to that in Cameroon?
Ensure brevity in your answer.  0.71. What is the ratio of the Emissions (1000 metric ton of CO2 equivalent) of 2000 in Bulgaria to that in Cameroon?
Provide a succinct answer. 0.28. What is the ratio of the Emissions (1000 metric ton of CO2 equivalent) in 2005 in Bulgaria to that in Cameroon?
Your answer should be very brief. 0.26. What is the ratio of the Emissions (1000 metric ton of CO2 equivalent) in 2008 in Bulgaria to that in Cameroon?
Your response must be concise. 0.16. What is the ratio of the Emissions (1000 metric ton of CO2 equivalent) of 1990 in Cambodia to that in Cameroon?
Your response must be concise. 1.72. What is the ratio of the Emissions (1000 metric ton of CO2 equivalent) of 2000 in Cambodia to that in Cameroon?
Make the answer very short. 1.45. What is the ratio of the Emissions (1000 metric ton of CO2 equivalent) in 2005 in Cambodia to that in Cameroon?
Your response must be concise. 1.92. What is the ratio of the Emissions (1000 metric ton of CO2 equivalent) of 2008 in Cambodia to that in Cameroon?
Keep it short and to the point. 1.66. What is the difference between the highest and the second highest Emissions (1000 metric ton of CO2 equivalent) of 1990?
Provide a succinct answer. 1.96e+05. What is the difference between the highest and the second highest Emissions (1000 metric ton of CO2 equivalent) of 2000?
Your answer should be compact. 2.33e+05. What is the difference between the highest and the second highest Emissions (1000 metric ton of CO2 equivalent) of 2005?
Keep it short and to the point. 2.87e+05. What is the difference between the highest and the second highest Emissions (1000 metric ton of CO2 equivalent) in 2008?
Your answer should be compact. 2.95e+05. What is the difference between the highest and the lowest Emissions (1000 metric ton of CO2 equivalent) in 1990?
Provide a short and direct response. 2.10e+05. What is the difference between the highest and the lowest Emissions (1000 metric ton of CO2 equivalent) of 2000?
Ensure brevity in your answer.  2.45e+05. What is the difference between the highest and the lowest Emissions (1000 metric ton of CO2 equivalent) of 2005?
Provide a short and direct response. 3.03e+05. What is the difference between the highest and the lowest Emissions (1000 metric ton of CO2 equivalent) in 2008?
Your answer should be compact. 3.16e+05. 